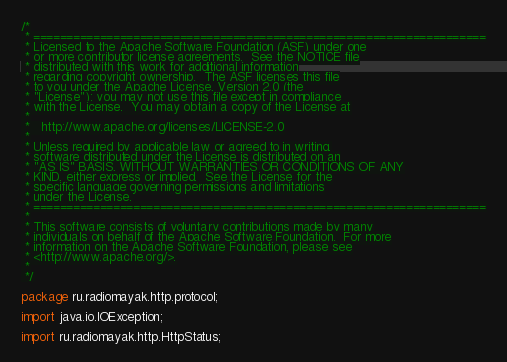Convert code to text. <code><loc_0><loc_0><loc_500><loc_500><_Java_>/*
 * ====================================================================
 * Licensed to the Apache Software Foundation (ASF) under one
 * or more contributor license agreements.  See the NOTICE file
 * distributed with this work for additional information
 * regarding copyright ownership.  The ASF licenses this file
 * to you under the Apache License, Version 2.0 (the
 * "License"); you may not use this file except in compliance
 * with the License.  You may obtain a copy of the License at
 *
 *   http://www.apache.org/licenses/LICENSE-2.0
 *
 * Unless required by applicable law or agreed to in writing,
 * software distributed under the License is distributed on an
 * "AS IS" BASIS, WITHOUT WARRANTIES OR CONDITIONS OF ANY
 * KIND, either express or implied.  See the License for the
 * specific language governing permissions and limitations
 * under the License.
 * ====================================================================
 *
 * This software consists of voluntary contributions made by many
 * individuals on behalf of the Apache Software Foundation.  For more
 * information on the Apache Software Foundation, please see
 * <http://www.apache.org/>.
 *
 */

package ru.radiomayak.http.protocol;

import java.io.IOException;

import ru.radiomayak.http.HttpStatus;</code> 